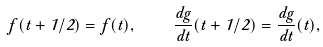<formula> <loc_0><loc_0><loc_500><loc_500>f ( t + 1 / 2 ) = f ( t ) , \quad \frac { d g } { d t } ( t + 1 / 2 ) = \frac { d g } { d t } ( t ) ,</formula> 